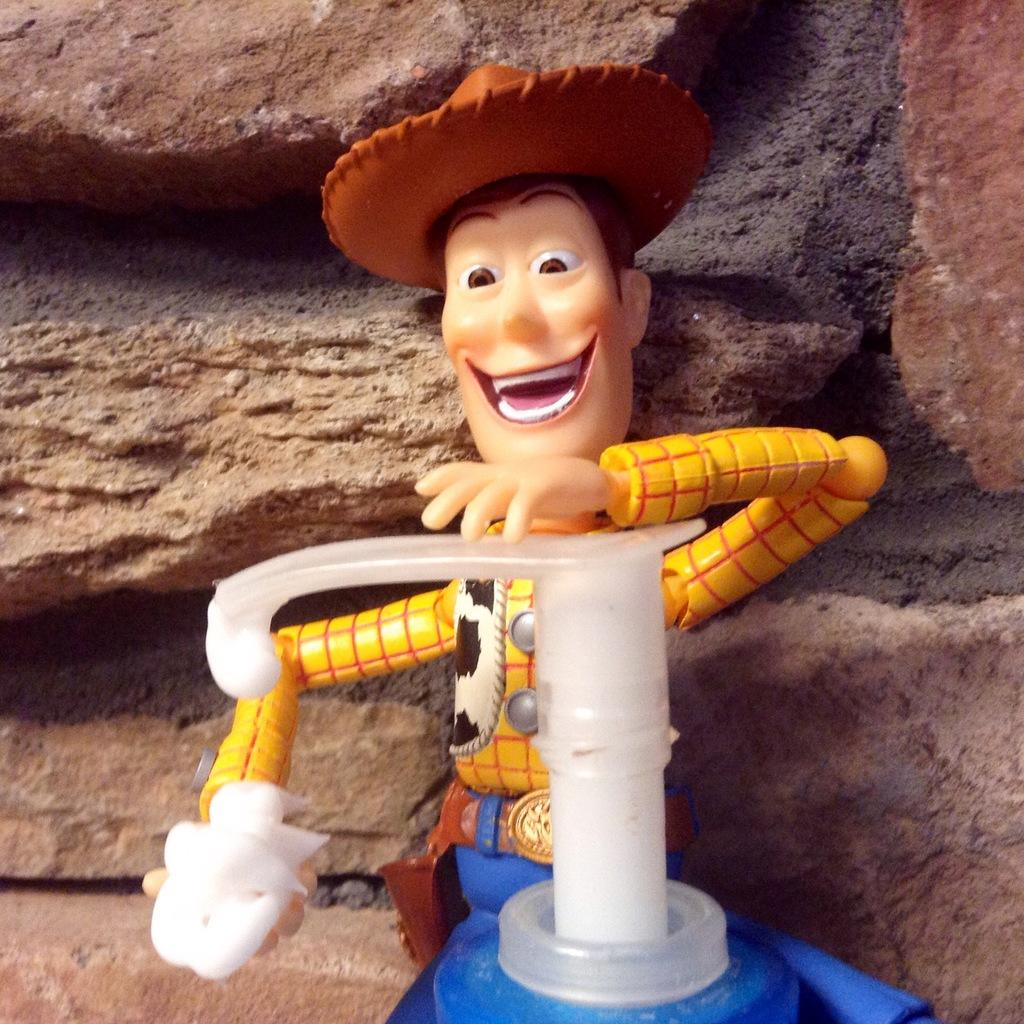What type of object is present in the image? There is a toy in the image. Can you describe the other object in the image? There is another object in the image, but its specific details are not mentioned in the facts. What can be seen in the background of the image? There are rocks in the background of the image. What type of head can be seen on the toy in the image? There is no information about the toy's appearance, including the presence of a head, in the provided facts. 